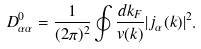Convert formula to latex. <formula><loc_0><loc_0><loc_500><loc_500>D ^ { 0 } _ { \alpha \alpha } = \frac { 1 } { ( 2 \pi ) ^ { 2 } } \oint \frac { d k _ { F } } { v ( { k } ) } | j _ { \alpha } ( { k } ) | ^ { 2 } .</formula> 